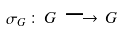<formula> <loc_0><loc_0><loc_500><loc_500>\sigma _ { G } \, \colon \, G \, \longrightarrow \, G</formula> 